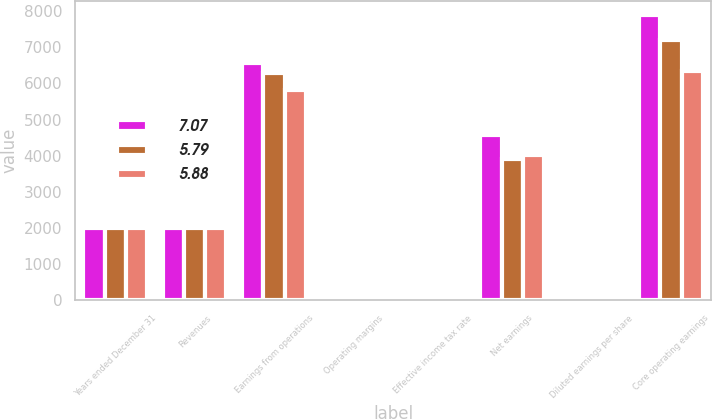<chart> <loc_0><loc_0><loc_500><loc_500><stacked_bar_chart><ecel><fcel>Years ended December 31<fcel>Revenues<fcel>Earnings from operations<fcel>Operating margins<fcel>Effective income tax rate<fcel>Net earnings<fcel>Diluted earnings per share<fcel>Core operating earnings<nl><fcel>7.07<fcel>2013<fcel>2012<fcel>6562<fcel>7.6<fcel>26.4<fcel>4585<fcel>5.96<fcel>7876<nl><fcel>5.79<fcel>2012<fcel>2012<fcel>6290<fcel>7.7<fcel>34<fcel>3900<fcel>5.11<fcel>7189<nl><fcel>5.88<fcel>2011<fcel>2012<fcel>5823<fcel>8.5<fcel>25.6<fcel>4018<fcel>5.34<fcel>6340<nl></chart> 